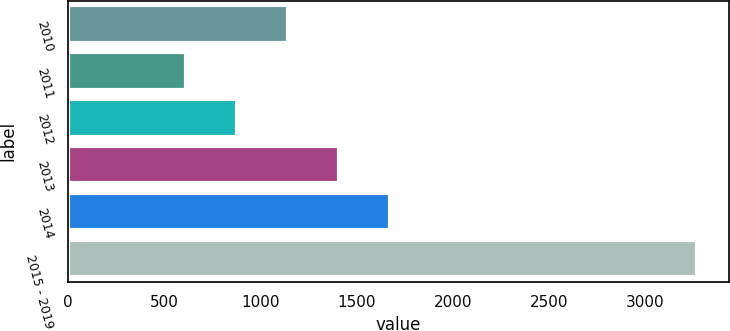Convert chart. <chart><loc_0><loc_0><loc_500><loc_500><bar_chart><fcel>2010<fcel>2011<fcel>2012<fcel>2013<fcel>2014<fcel>2015 - 2019<nl><fcel>1144<fcel>612<fcel>878<fcel>1410<fcel>1676<fcel>3272<nl></chart> 